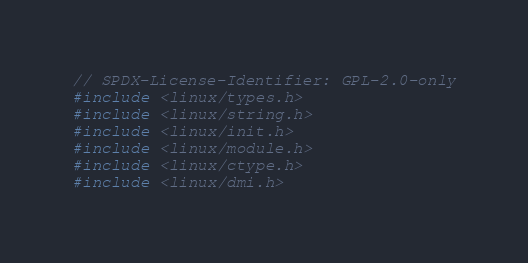Convert code to text. <code><loc_0><loc_0><loc_500><loc_500><_C_>// SPDX-License-Identifier: GPL-2.0-only
#include <linux/types.h>
#include <linux/string.h>
#include <linux/init.h>
#include <linux/module.h>
#include <linux/ctype.h>
#include <linux/dmi.h></code> 